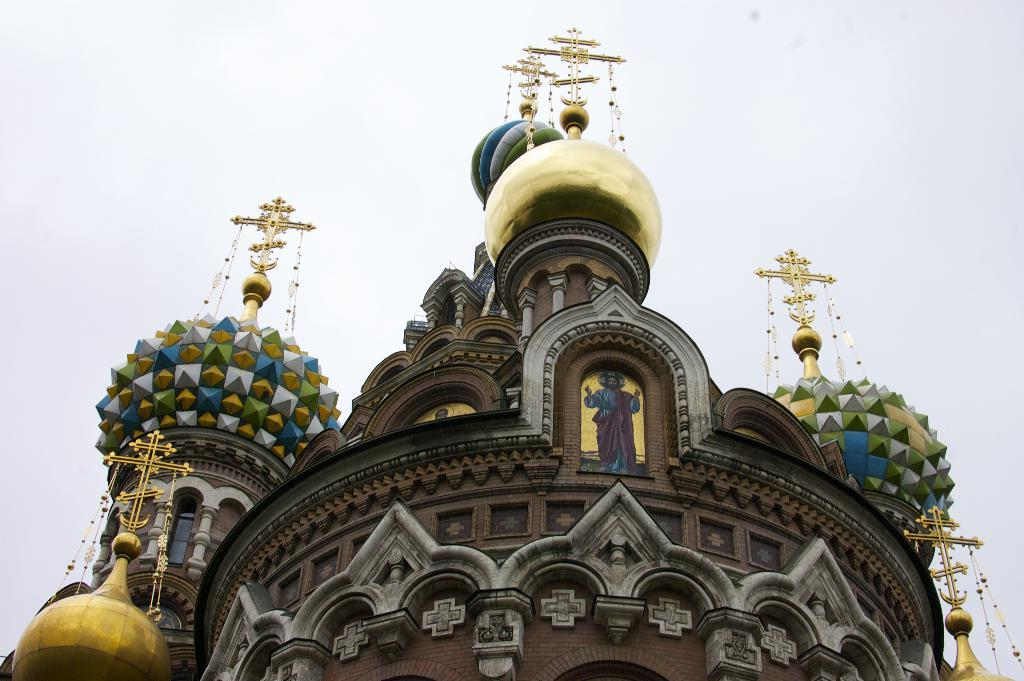What type of building is in the image? There is a church building in the image. What features can be seen on the church building? The church building has sculptures. What symbol is present on the sculptures? The sculptures have a cross symbol on them. What can be seen in the background of the image? There is a sky visible in the background of the image. Is there a spy hiding behind the church building in the image? There is no indication of a spy or any hidden figure in the image; it only shows a church building with sculptures and a sky in the background. 